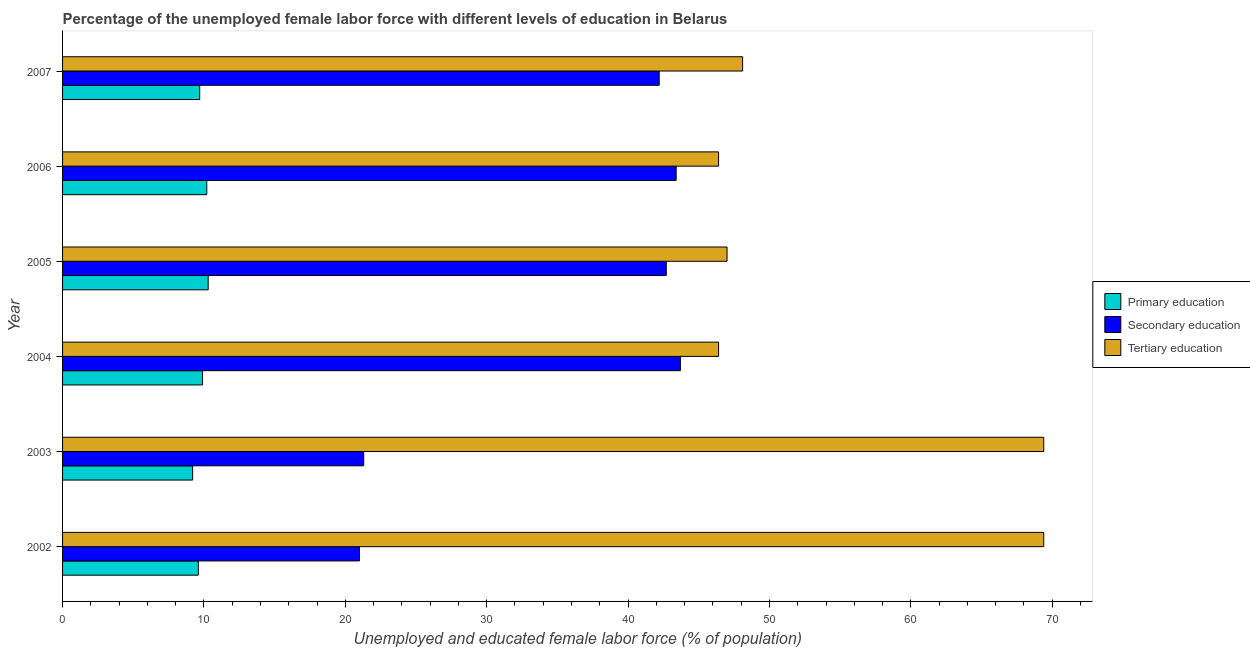How many different coloured bars are there?
Provide a short and direct response. 3. How many groups of bars are there?
Provide a succinct answer. 6. Are the number of bars per tick equal to the number of legend labels?
Your answer should be compact. Yes. How many bars are there on the 2nd tick from the top?
Your answer should be very brief. 3. What is the label of the 2nd group of bars from the top?
Provide a short and direct response. 2006. In how many cases, is the number of bars for a given year not equal to the number of legend labels?
Your answer should be very brief. 0. What is the percentage of female labor force who received tertiary education in 2002?
Your answer should be compact. 69.4. Across all years, what is the maximum percentage of female labor force who received primary education?
Offer a terse response. 10.3. Across all years, what is the minimum percentage of female labor force who received primary education?
Your answer should be compact. 9.2. In which year was the percentage of female labor force who received primary education minimum?
Offer a terse response. 2003. What is the total percentage of female labor force who received primary education in the graph?
Make the answer very short. 58.9. What is the difference between the percentage of female labor force who received secondary education in 2004 and that in 2007?
Offer a very short reply. 1.5. What is the difference between the percentage of female labor force who received tertiary education in 2003 and the percentage of female labor force who received primary education in 2007?
Offer a terse response. 59.7. What is the average percentage of female labor force who received tertiary education per year?
Make the answer very short. 54.45. In the year 2005, what is the difference between the percentage of female labor force who received primary education and percentage of female labor force who received secondary education?
Provide a succinct answer. -32.4. In how many years, is the percentage of female labor force who received primary education greater than 40 %?
Give a very brief answer. 0. What is the ratio of the percentage of female labor force who received secondary education in 2002 to that in 2007?
Offer a terse response. 0.5. Is the percentage of female labor force who received primary education in 2006 less than that in 2007?
Offer a terse response. No. Is the difference between the percentage of female labor force who received secondary education in 2002 and 2003 greater than the difference between the percentage of female labor force who received primary education in 2002 and 2003?
Ensure brevity in your answer.  No. What is the difference between the highest and the lowest percentage of female labor force who received secondary education?
Give a very brief answer. 22.7. Is the sum of the percentage of female labor force who received tertiary education in 2002 and 2005 greater than the maximum percentage of female labor force who received secondary education across all years?
Offer a very short reply. Yes. Is it the case that in every year, the sum of the percentage of female labor force who received primary education and percentage of female labor force who received secondary education is greater than the percentage of female labor force who received tertiary education?
Provide a short and direct response. No. How many years are there in the graph?
Give a very brief answer. 6. What is the difference between two consecutive major ticks on the X-axis?
Your response must be concise. 10. Are the values on the major ticks of X-axis written in scientific E-notation?
Your response must be concise. No. How many legend labels are there?
Your answer should be compact. 3. What is the title of the graph?
Your response must be concise. Percentage of the unemployed female labor force with different levels of education in Belarus. Does "Male employers" appear as one of the legend labels in the graph?
Keep it short and to the point. No. What is the label or title of the X-axis?
Ensure brevity in your answer.  Unemployed and educated female labor force (% of population). What is the Unemployed and educated female labor force (% of population) in Primary education in 2002?
Your response must be concise. 9.6. What is the Unemployed and educated female labor force (% of population) in Secondary education in 2002?
Keep it short and to the point. 21. What is the Unemployed and educated female labor force (% of population) of Tertiary education in 2002?
Ensure brevity in your answer.  69.4. What is the Unemployed and educated female labor force (% of population) of Primary education in 2003?
Keep it short and to the point. 9.2. What is the Unemployed and educated female labor force (% of population) of Secondary education in 2003?
Provide a short and direct response. 21.3. What is the Unemployed and educated female labor force (% of population) of Tertiary education in 2003?
Make the answer very short. 69.4. What is the Unemployed and educated female labor force (% of population) in Primary education in 2004?
Your answer should be compact. 9.9. What is the Unemployed and educated female labor force (% of population) of Secondary education in 2004?
Your answer should be compact. 43.7. What is the Unemployed and educated female labor force (% of population) in Tertiary education in 2004?
Make the answer very short. 46.4. What is the Unemployed and educated female labor force (% of population) of Primary education in 2005?
Your answer should be very brief. 10.3. What is the Unemployed and educated female labor force (% of population) in Secondary education in 2005?
Ensure brevity in your answer.  42.7. What is the Unemployed and educated female labor force (% of population) of Primary education in 2006?
Your answer should be very brief. 10.2. What is the Unemployed and educated female labor force (% of population) of Secondary education in 2006?
Provide a succinct answer. 43.4. What is the Unemployed and educated female labor force (% of population) of Tertiary education in 2006?
Ensure brevity in your answer.  46.4. What is the Unemployed and educated female labor force (% of population) of Primary education in 2007?
Your response must be concise. 9.7. What is the Unemployed and educated female labor force (% of population) in Secondary education in 2007?
Offer a very short reply. 42.2. What is the Unemployed and educated female labor force (% of population) of Tertiary education in 2007?
Your response must be concise. 48.1. Across all years, what is the maximum Unemployed and educated female labor force (% of population) in Primary education?
Provide a succinct answer. 10.3. Across all years, what is the maximum Unemployed and educated female labor force (% of population) in Secondary education?
Provide a succinct answer. 43.7. Across all years, what is the maximum Unemployed and educated female labor force (% of population) of Tertiary education?
Your answer should be compact. 69.4. Across all years, what is the minimum Unemployed and educated female labor force (% of population) in Primary education?
Ensure brevity in your answer.  9.2. Across all years, what is the minimum Unemployed and educated female labor force (% of population) in Tertiary education?
Your answer should be compact. 46.4. What is the total Unemployed and educated female labor force (% of population) in Primary education in the graph?
Give a very brief answer. 58.9. What is the total Unemployed and educated female labor force (% of population) in Secondary education in the graph?
Keep it short and to the point. 214.3. What is the total Unemployed and educated female labor force (% of population) in Tertiary education in the graph?
Your response must be concise. 326.7. What is the difference between the Unemployed and educated female labor force (% of population) of Primary education in 2002 and that in 2003?
Make the answer very short. 0.4. What is the difference between the Unemployed and educated female labor force (% of population) in Secondary education in 2002 and that in 2003?
Provide a short and direct response. -0.3. What is the difference between the Unemployed and educated female labor force (% of population) in Primary education in 2002 and that in 2004?
Provide a succinct answer. -0.3. What is the difference between the Unemployed and educated female labor force (% of population) of Secondary education in 2002 and that in 2004?
Provide a short and direct response. -22.7. What is the difference between the Unemployed and educated female labor force (% of population) in Secondary education in 2002 and that in 2005?
Keep it short and to the point. -21.7. What is the difference between the Unemployed and educated female labor force (% of population) in Tertiary education in 2002 and that in 2005?
Your answer should be very brief. 22.4. What is the difference between the Unemployed and educated female labor force (% of population) of Secondary education in 2002 and that in 2006?
Your answer should be compact. -22.4. What is the difference between the Unemployed and educated female labor force (% of population) of Tertiary education in 2002 and that in 2006?
Keep it short and to the point. 23. What is the difference between the Unemployed and educated female labor force (% of population) of Secondary education in 2002 and that in 2007?
Make the answer very short. -21.2. What is the difference between the Unemployed and educated female labor force (% of population) of Tertiary education in 2002 and that in 2007?
Ensure brevity in your answer.  21.3. What is the difference between the Unemployed and educated female labor force (% of population) in Primary education in 2003 and that in 2004?
Your answer should be very brief. -0.7. What is the difference between the Unemployed and educated female labor force (% of population) in Secondary education in 2003 and that in 2004?
Provide a succinct answer. -22.4. What is the difference between the Unemployed and educated female labor force (% of population) in Primary education in 2003 and that in 2005?
Offer a terse response. -1.1. What is the difference between the Unemployed and educated female labor force (% of population) of Secondary education in 2003 and that in 2005?
Provide a short and direct response. -21.4. What is the difference between the Unemployed and educated female labor force (% of population) in Tertiary education in 2003 and that in 2005?
Offer a very short reply. 22.4. What is the difference between the Unemployed and educated female labor force (% of population) of Primary education in 2003 and that in 2006?
Ensure brevity in your answer.  -1. What is the difference between the Unemployed and educated female labor force (% of population) of Secondary education in 2003 and that in 2006?
Offer a terse response. -22.1. What is the difference between the Unemployed and educated female labor force (% of population) in Secondary education in 2003 and that in 2007?
Offer a terse response. -20.9. What is the difference between the Unemployed and educated female labor force (% of population) in Tertiary education in 2003 and that in 2007?
Your answer should be very brief. 21.3. What is the difference between the Unemployed and educated female labor force (% of population) of Secondary education in 2004 and that in 2005?
Your response must be concise. 1. What is the difference between the Unemployed and educated female labor force (% of population) of Tertiary education in 2004 and that in 2005?
Offer a terse response. -0.6. What is the difference between the Unemployed and educated female labor force (% of population) in Primary education in 2004 and that in 2006?
Your response must be concise. -0.3. What is the difference between the Unemployed and educated female labor force (% of population) in Tertiary education in 2004 and that in 2006?
Give a very brief answer. 0. What is the difference between the Unemployed and educated female labor force (% of population) of Secondary education in 2004 and that in 2007?
Give a very brief answer. 1.5. What is the difference between the Unemployed and educated female labor force (% of population) of Primary education in 2005 and that in 2007?
Your response must be concise. 0.6. What is the difference between the Unemployed and educated female labor force (% of population) in Tertiary education in 2005 and that in 2007?
Make the answer very short. -1.1. What is the difference between the Unemployed and educated female labor force (% of population) in Primary education in 2006 and that in 2007?
Keep it short and to the point. 0.5. What is the difference between the Unemployed and educated female labor force (% of population) of Primary education in 2002 and the Unemployed and educated female labor force (% of population) of Secondary education in 2003?
Keep it short and to the point. -11.7. What is the difference between the Unemployed and educated female labor force (% of population) in Primary education in 2002 and the Unemployed and educated female labor force (% of population) in Tertiary education in 2003?
Your answer should be compact. -59.8. What is the difference between the Unemployed and educated female labor force (% of population) in Secondary education in 2002 and the Unemployed and educated female labor force (% of population) in Tertiary education in 2003?
Ensure brevity in your answer.  -48.4. What is the difference between the Unemployed and educated female labor force (% of population) in Primary education in 2002 and the Unemployed and educated female labor force (% of population) in Secondary education in 2004?
Your answer should be compact. -34.1. What is the difference between the Unemployed and educated female labor force (% of population) of Primary education in 2002 and the Unemployed and educated female labor force (% of population) of Tertiary education in 2004?
Give a very brief answer. -36.8. What is the difference between the Unemployed and educated female labor force (% of population) in Secondary education in 2002 and the Unemployed and educated female labor force (% of population) in Tertiary education in 2004?
Provide a short and direct response. -25.4. What is the difference between the Unemployed and educated female labor force (% of population) of Primary education in 2002 and the Unemployed and educated female labor force (% of population) of Secondary education in 2005?
Provide a short and direct response. -33.1. What is the difference between the Unemployed and educated female labor force (% of population) of Primary education in 2002 and the Unemployed and educated female labor force (% of population) of Tertiary education in 2005?
Your answer should be compact. -37.4. What is the difference between the Unemployed and educated female labor force (% of population) in Secondary education in 2002 and the Unemployed and educated female labor force (% of population) in Tertiary education in 2005?
Provide a short and direct response. -26. What is the difference between the Unemployed and educated female labor force (% of population) of Primary education in 2002 and the Unemployed and educated female labor force (% of population) of Secondary education in 2006?
Ensure brevity in your answer.  -33.8. What is the difference between the Unemployed and educated female labor force (% of population) in Primary education in 2002 and the Unemployed and educated female labor force (% of population) in Tertiary education in 2006?
Your response must be concise. -36.8. What is the difference between the Unemployed and educated female labor force (% of population) of Secondary education in 2002 and the Unemployed and educated female labor force (% of population) of Tertiary education in 2006?
Keep it short and to the point. -25.4. What is the difference between the Unemployed and educated female labor force (% of population) of Primary education in 2002 and the Unemployed and educated female labor force (% of population) of Secondary education in 2007?
Provide a short and direct response. -32.6. What is the difference between the Unemployed and educated female labor force (% of population) of Primary education in 2002 and the Unemployed and educated female labor force (% of population) of Tertiary education in 2007?
Give a very brief answer. -38.5. What is the difference between the Unemployed and educated female labor force (% of population) in Secondary education in 2002 and the Unemployed and educated female labor force (% of population) in Tertiary education in 2007?
Ensure brevity in your answer.  -27.1. What is the difference between the Unemployed and educated female labor force (% of population) in Primary education in 2003 and the Unemployed and educated female labor force (% of population) in Secondary education in 2004?
Give a very brief answer. -34.5. What is the difference between the Unemployed and educated female labor force (% of population) in Primary education in 2003 and the Unemployed and educated female labor force (% of population) in Tertiary education in 2004?
Offer a very short reply. -37.2. What is the difference between the Unemployed and educated female labor force (% of population) of Secondary education in 2003 and the Unemployed and educated female labor force (% of population) of Tertiary education in 2004?
Make the answer very short. -25.1. What is the difference between the Unemployed and educated female labor force (% of population) of Primary education in 2003 and the Unemployed and educated female labor force (% of population) of Secondary education in 2005?
Ensure brevity in your answer.  -33.5. What is the difference between the Unemployed and educated female labor force (% of population) in Primary education in 2003 and the Unemployed and educated female labor force (% of population) in Tertiary education in 2005?
Offer a very short reply. -37.8. What is the difference between the Unemployed and educated female labor force (% of population) of Secondary education in 2003 and the Unemployed and educated female labor force (% of population) of Tertiary education in 2005?
Keep it short and to the point. -25.7. What is the difference between the Unemployed and educated female labor force (% of population) of Primary education in 2003 and the Unemployed and educated female labor force (% of population) of Secondary education in 2006?
Provide a succinct answer. -34.2. What is the difference between the Unemployed and educated female labor force (% of population) of Primary education in 2003 and the Unemployed and educated female labor force (% of population) of Tertiary education in 2006?
Provide a succinct answer. -37.2. What is the difference between the Unemployed and educated female labor force (% of population) of Secondary education in 2003 and the Unemployed and educated female labor force (% of population) of Tertiary education in 2006?
Make the answer very short. -25.1. What is the difference between the Unemployed and educated female labor force (% of population) in Primary education in 2003 and the Unemployed and educated female labor force (% of population) in Secondary education in 2007?
Your response must be concise. -33. What is the difference between the Unemployed and educated female labor force (% of population) in Primary education in 2003 and the Unemployed and educated female labor force (% of population) in Tertiary education in 2007?
Offer a terse response. -38.9. What is the difference between the Unemployed and educated female labor force (% of population) of Secondary education in 2003 and the Unemployed and educated female labor force (% of population) of Tertiary education in 2007?
Your answer should be very brief. -26.8. What is the difference between the Unemployed and educated female labor force (% of population) in Primary education in 2004 and the Unemployed and educated female labor force (% of population) in Secondary education in 2005?
Provide a succinct answer. -32.8. What is the difference between the Unemployed and educated female labor force (% of population) of Primary education in 2004 and the Unemployed and educated female labor force (% of population) of Tertiary education in 2005?
Give a very brief answer. -37.1. What is the difference between the Unemployed and educated female labor force (% of population) in Primary education in 2004 and the Unemployed and educated female labor force (% of population) in Secondary education in 2006?
Provide a succinct answer. -33.5. What is the difference between the Unemployed and educated female labor force (% of population) of Primary education in 2004 and the Unemployed and educated female labor force (% of population) of Tertiary education in 2006?
Keep it short and to the point. -36.5. What is the difference between the Unemployed and educated female labor force (% of population) in Secondary education in 2004 and the Unemployed and educated female labor force (% of population) in Tertiary education in 2006?
Provide a short and direct response. -2.7. What is the difference between the Unemployed and educated female labor force (% of population) of Primary education in 2004 and the Unemployed and educated female labor force (% of population) of Secondary education in 2007?
Give a very brief answer. -32.3. What is the difference between the Unemployed and educated female labor force (% of population) in Primary education in 2004 and the Unemployed and educated female labor force (% of population) in Tertiary education in 2007?
Your response must be concise. -38.2. What is the difference between the Unemployed and educated female labor force (% of population) of Secondary education in 2004 and the Unemployed and educated female labor force (% of population) of Tertiary education in 2007?
Make the answer very short. -4.4. What is the difference between the Unemployed and educated female labor force (% of population) in Primary education in 2005 and the Unemployed and educated female labor force (% of population) in Secondary education in 2006?
Your answer should be compact. -33.1. What is the difference between the Unemployed and educated female labor force (% of population) of Primary education in 2005 and the Unemployed and educated female labor force (% of population) of Tertiary education in 2006?
Keep it short and to the point. -36.1. What is the difference between the Unemployed and educated female labor force (% of population) of Primary education in 2005 and the Unemployed and educated female labor force (% of population) of Secondary education in 2007?
Your response must be concise. -31.9. What is the difference between the Unemployed and educated female labor force (% of population) of Primary education in 2005 and the Unemployed and educated female labor force (% of population) of Tertiary education in 2007?
Your answer should be compact. -37.8. What is the difference between the Unemployed and educated female labor force (% of population) of Primary education in 2006 and the Unemployed and educated female labor force (% of population) of Secondary education in 2007?
Give a very brief answer. -32. What is the difference between the Unemployed and educated female labor force (% of population) in Primary education in 2006 and the Unemployed and educated female labor force (% of population) in Tertiary education in 2007?
Provide a succinct answer. -37.9. What is the difference between the Unemployed and educated female labor force (% of population) of Secondary education in 2006 and the Unemployed and educated female labor force (% of population) of Tertiary education in 2007?
Provide a short and direct response. -4.7. What is the average Unemployed and educated female labor force (% of population) of Primary education per year?
Give a very brief answer. 9.82. What is the average Unemployed and educated female labor force (% of population) in Secondary education per year?
Your answer should be compact. 35.72. What is the average Unemployed and educated female labor force (% of population) of Tertiary education per year?
Provide a short and direct response. 54.45. In the year 2002, what is the difference between the Unemployed and educated female labor force (% of population) in Primary education and Unemployed and educated female labor force (% of population) in Tertiary education?
Offer a terse response. -59.8. In the year 2002, what is the difference between the Unemployed and educated female labor force (% of population) of Secondary education and Unemployed and educated female labor force (% of population) of Tertiary education?
Your answer should be very brief. -48.4. In the year 2003, what is the difference between the Unemployed and educated female labor force (% of population) of Primary education and Unemployed and educated female labor force (% of population) of Tertiary education?
Give a very brief answer. -60.2. In the year 2003, what is the difference between the Unemployed and educated female labor force (% of population) of Secondary education and Unemployed and educated female labor force (% of population) of Tertiary education?
Your answer should be very brief. -48.1. In the year 2004, what is the difference between the Unemployed and educated female labor force (% of population) of Primary education and Unemployed and educated female labor force (% of population) of Secondary education?
Your answer should be compact. -33.8. In the year 2004, what is the difference between the Unemployed and educated female labor force (% of population) in Primary education and Unemployed and educated female labor force (% of population) in Tertiary education?
Ensure brevity in your answer.  -36.5. In the year 2005, what is the difference between the Unemployed and educated female labor force (% of population) in Primary education and Unemployed and educated female labor force (% of population) in Secondary education?
Offer a terse response. -32.4. In the year 2005, what is the difference between the Unemployed and educated female labor force (% of population) in Primary education and Unemployed and educated female labor force (% of population) in Tertiary education?
Your response must be concise. -36.7. In the year 2005, what is the difference between the Unemployed and educated female labor force (% of population) of Secondary education and Unemployed and educated female labor force (% of population) of Tertiary education?
Give a very brief answer. -4.3. In the year 2006, what is the difference between the Unemployed and educated female labor force (% of population) in Primary education and Unemployed and educated female labor force (% of population) in Secondary education?
Your answer should be very brief. -33.2. In the year 2006, what is the difference between the Unemployed and educated female labor force (% of population) in Primary education and Unemployed and educated female labor force (% of population) in Tertiary education?
Provide a succinct answer. -36.2. In the year 2006, what is the difference between the Unemployed and educated female labor force (% of population) of Secondary education and Unemployed and educated female labor force (% of population) of Tertiary education?
Make the answer very short. -3. In the year 2007, what is the difference between the Unemployed and educated female labor force (% of population) of Primary education and Unemployed and educated female labor force (% of population) of Secondary education?
Offer a very short reply. -32.5. In the year 2007, what is the difference between the Unemployed and educated female labor force (% of population) in Primary education and Unemployed and educated female labor force (% of population) in Tertiary education?
Offer a very short reply. -38.4. What is the ratio of the Unemployed and educated female labor force (% of population) in Primary education in 2002 to that in 2003?
Your answer should be very brief. 1.04. What is the ratio of the Unemployed and educated female labor force (% of population) of Secondary education in 2002 to that in 2003?
Offer a very short reply. 0.99. What is the ratio of the Unemployed and educated female labor force (% of population) in Primary education in 2002 to that in 2004?
Your answer should be compact. 0.97. What is the ratio of the Unemployed and educated female labor force (% of population) in Secondary education in 2002 to that in 2004?
Ensure brevity in your answer.  0.48. What is the ratio of the Unemployed and educated female labor force (% of population) of Tertiary education in 2002 to that in 2004?
Give a very brief answer. 1.5. What is the ratio of the Unemployed and educated female labor force (% of population) of Primary education in 2002 to that in 2005?
Offer a terse response. 0.93. What is the ratio of the Unemployed and educated female labor force (% of population) of Secondary education in 2002 to that in 2005?
Your answer should be very brief. 0.49. What is the ratio of the Unemployed and educated female labor force (% of population) in Tertiary education in 2002 to that in 2005?
Keep it short and to the point. 1.48. What is the ratio of the Unemployed and educated female labor force (% of population) in Secondary education in 2002 to that in 2006?
Your answer should be compact. 0.48. What is the ratio of the Unemployed and educated female labor force (% of population) in Tertiary education in 2002 to that in 2006?
Ensure brevity in your answer.  1.5. What is the ratio of the Unemployed and educated female labor force (% of population) of Primary education in 2002 to that in 2007?
Keep it short and to the point. 0.99. What is the ratio of the Unemployed and educated female labor force (% of population) in Secondary education in 2002 to that in 2007?
Give a very brief answer. 0.5. What is the ratio of the Unemployed and educated female labor force (% of population) in Tertiary education in 2002 to that in 2007?
Provide a succinct answer. 1.44. What is the ratio of the Unemployed and educated female labor force (% of population) in Primary education in 2003 to that in 2004?
Provide a succinct answer. 0.93. What is the ratio of the Unemployed and educated female labor force (% of population) of Secondary education in 2003 to that in 2004?
Provide a short and direct response. 0.49. What is the ratio of the Unemployed and educated female labor force (% of population) of Tertiary education in 2003 to that in 2004?
Your response must be concise. 1.5. What is the ratio of the Unemployed and educated female labor force (% of population) in Primary education in 2003 to that in 2005?
Give a very brief answer. 0.89. What is the ratio of the Unemployed and educated female labor force (% of population) in Secondary education in 2003 to that in 2005?
Provide a succinct answer. 0.5. What is the ratio of the Unemployed and educated female labor force (% of population) in Tertiary education in 2003 to that in 2005?
Keep it short and to the point. 1.48. What is the ratio of the Unemployed and educated female labor force (% of population) in Primary education in 2003 to that in 2006?
Provide a succinct answer. 0.9. What is the ratio of the Unemployed and educated female labor force (% of population) in Secondary education in 2003 to that in 2006?
Your response must be concise. 0.49. What is the ratio of the Unemployed and educated female labor force (% of population) in Tertiary education in 2003 to that in 2006?
Offer a terse response. 1.5. What is the ratio of the Unemployed and educated female labor force (% of population) of Primary education in 2003 to that in 2007?
Your response must be concise. 0.95. What is the ratio of the Unemployed and educated female labor force (% of population) in Secondary education in 2003 to that in 2007?
Make the answer very short. 0.5. What is the ratio of the Unemployed and educated female labor force (% of population) in Tertiary education in 2003 to that in 2007?
Provide a short and direct response. 1.44. What is the ratio of the Unemployed and educated female labor force (% of population) of Primary education in 2004 to that in 2005?
Make the answer very short. 0.96. What is the ratio of the Unemployed and educated female labor force (% of population) of Secondary education in 2004 to that in 2005?
Give a very brief answer. 1.02. What is the ratio of the Unemployed and educated female labor force (% of population) of Tertiary education in 2004 to that in 2005?
Offer a very short reply. 0.99. What is the ratio of the Unemployed and educated female labor force (% of population) of Primary education in 2004 to that in 2006?
Your answer should be compact. 0.97. What is the ratio of the Unemployed and educated female labor force (% of population) in Tertiary education in 2004 to that in 2006?
Offer a very short reply. 1. What is the ratio of the Unemployed and educated female labor force (% of population) of Primary education in 2004 to that in 2007?
Your answer should be very brief. 1.02. What is the ratio of the Unemployed and educated female labor force (% of population) in Secondary education in 2004 to that in 2007?
Offer a terse response. 1.04. What is the ratio of the Unemployed and educated female labor force (% of population) in Tertiary education in 2004 to that in 2007?
Provide a succinct answer. 0.96. What is the ratio of the Unemployed and educated female labor force (% of population) of Primary education in 2005 to that in 2006?
Provide a short and direct response. 1.01. What is the ratio of the Unemployed and educated female labor force (% of population) of Secondary education in 2005 to that in 2006?
Provide a succinct answer. 0.98. What is the ratio of the Unemployed and educated female labor force (% of population) of Tertiary education in 2005 to that in 2006?
Offer a very short reply. 1.01. What is the ratio of the Unemployed and educated female labor force (% of population) in Primary education in 2005 to that in 2007?
Keep it short and to the point. 1.06. What is the ratio of the Unemployed and educated female labor force (% of population) of Secondary education in 2005 to that in 2007?
Offer a very short reply. 1.01. What is the ratio of the Unemployed and educated female labor force (% of population) in Tertiary education in 2005 to that in 2007?
Offer a very short reply. 0.98. What is the ratio of the Unemployed and educated female labor force (% of population) of Primary education in 2006 to that in 2007?
Your answer should be compact. 1.05. What is the ratio of the Unemployed and educated female labor force (% of population) of Secondary education in 2006 to that in 2007?
Offer a terse response. 1.03. What is the ratio of the Unemployed and educated female labor force (% of population) of Tertiary education in 2006 to that in 2007?
Give a very brief answer. 0.96. What is the difference between the highest and the lowest Unemployed and educated female labor force (% of population) in Primary education?
Your answer should be very brief. 1.1. What is the difference between the highest and the lowest Unemployed and educated female labor force (% of population) of Secondary education?
Your answer should be compact. 22.7. 